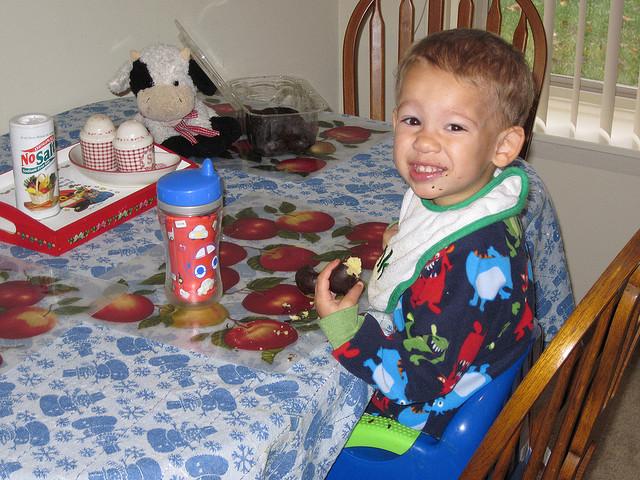Is the child holding a computer?
Quick response, please. No. What is all over his pajamas?
Give a very brief answer. Monsters. What is the boy drinking from?
Be succinct. Sippy cup. Are the blinds open?
Answer briefly. Yes. Where is her name tag placed?
Keep it brief. Cup. What are some of the animals in this scene?
Concise answer only. Cow. What image or pattern is on the baby's bib?
Be succinct. Monsters. 